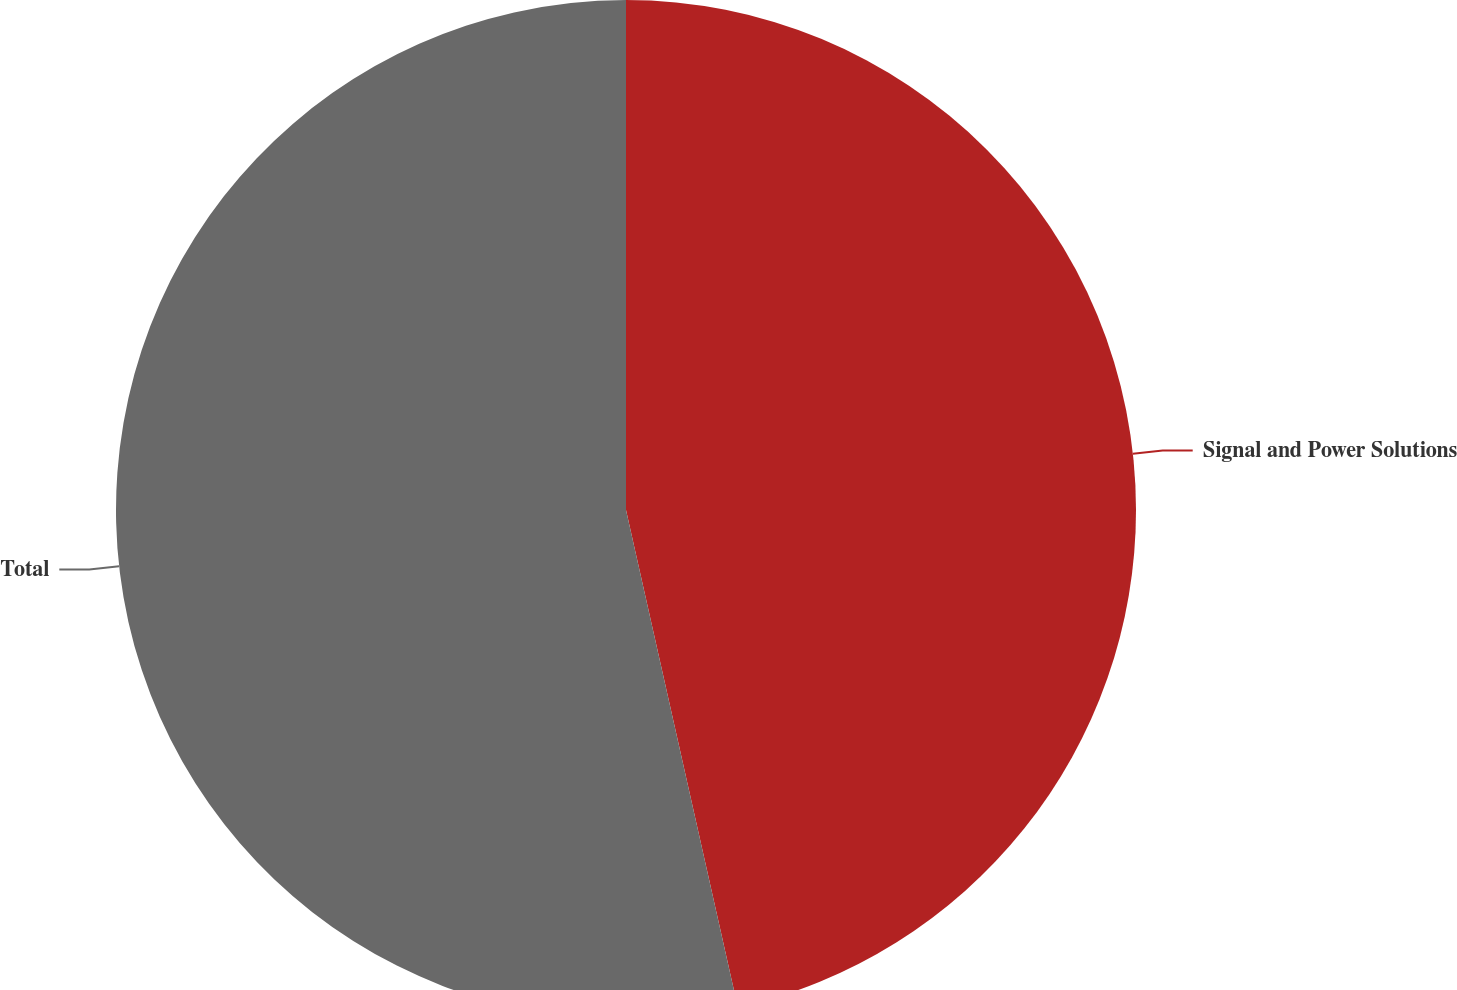Convert chart. <chart><loc_0><loc_0><loc_500><loc_500><pie_chart><fcel>Signal and Power Solutions<fcel>Total<nl><fcel>46.48%<fcel>53.52%<nl></chart> 